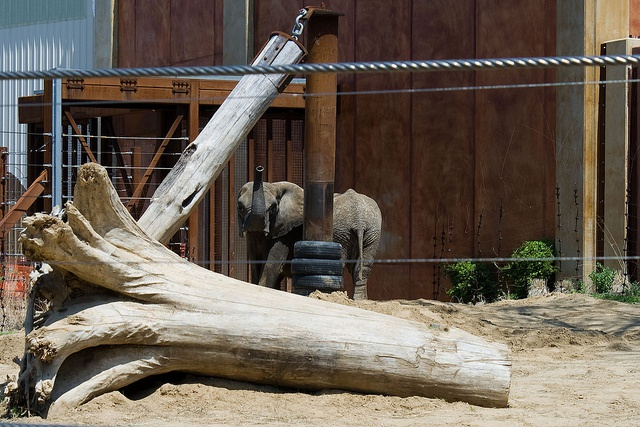Describe the objects in this image and their specific colors. I can see elephant in gray, black, and darkgray tones and elephant in gray, black, and darkgray tones in this image. 